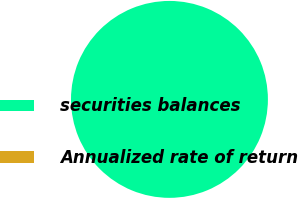Convert chart to OTSL. <chart><loc_0><loc_0><loc_500><loc_500><pie_chart><fcel>securities balances<fcel>Annualized rate of return<nl><fcel>100.0%<fcel>0.0%<nl></chart> 